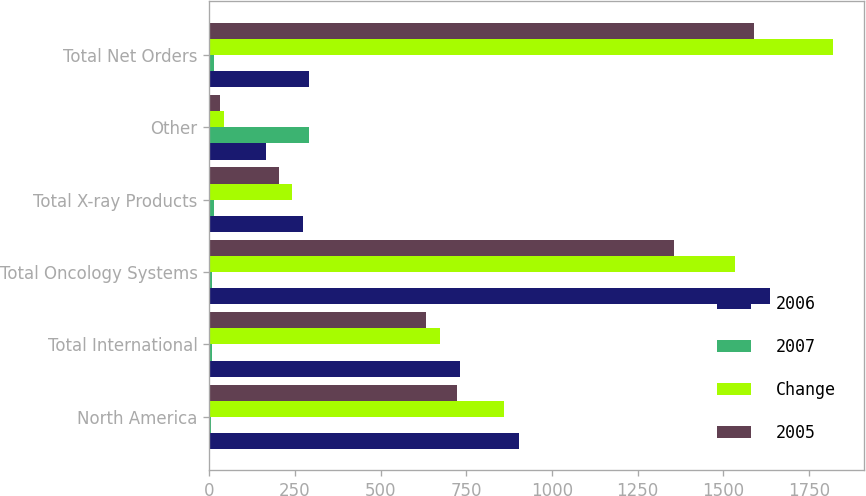Convert chart. <chart><loc_0><loc_0><loc_500><loc_500><stacked_bar_chart><ecel><fcel>North America<fcel>Total International<fcel>Total Oncology Systems<fcel>Total X-ray Products<fcel>Other<fcel>Total Net Orders<nl><fcel>2006<fcel>905<fcel>731<fcel>1636<fcel>273<fcel>166<fcel>292<nl><fcel>2007<fcel>5<fcel>9<fcel>7<fcel>13<fcel>292<fcel>14<nl><fcel>Change<fcel>861<fcel>674<fcel>1535<fcel>242<fcel>43<fcel>1820<nl><fcel>2005<fcel>722<fcel>633<fcel>1355<fcel>204<fcel>32<fcel>1591<nl></chart> 